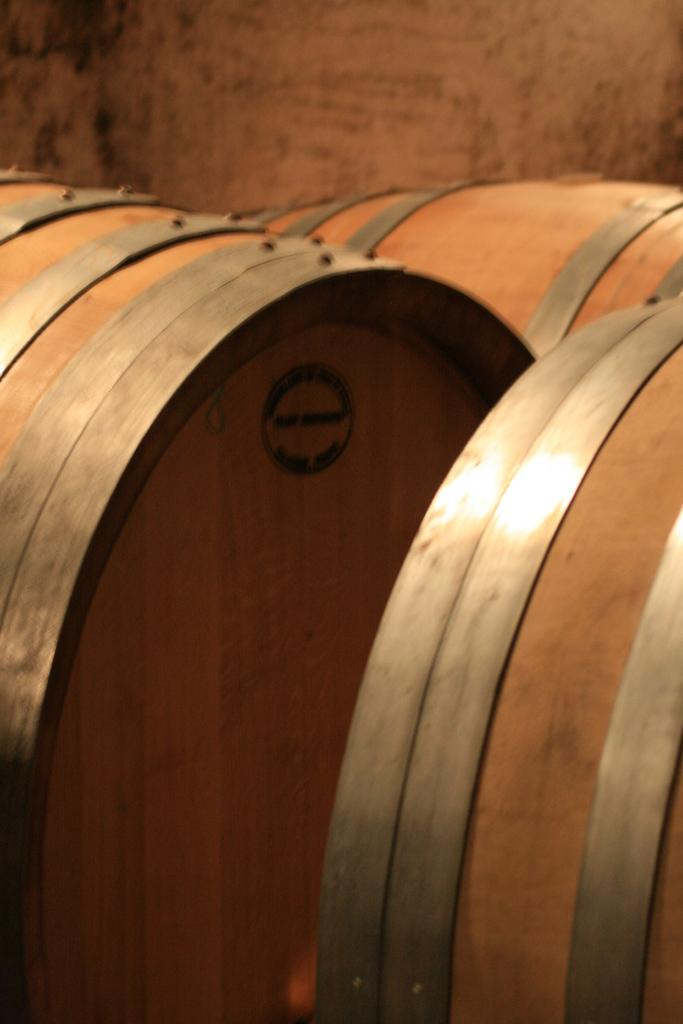What objects are present in the image? There are barrels in the image. What can be seen in the background of the image? There is a wall in the background of the image. How many drawers are visible in the image? There are no drawers present in the image. What type of servant is depicted in the image? There is no servant depicted in the image; it only features barrels and a wall. 